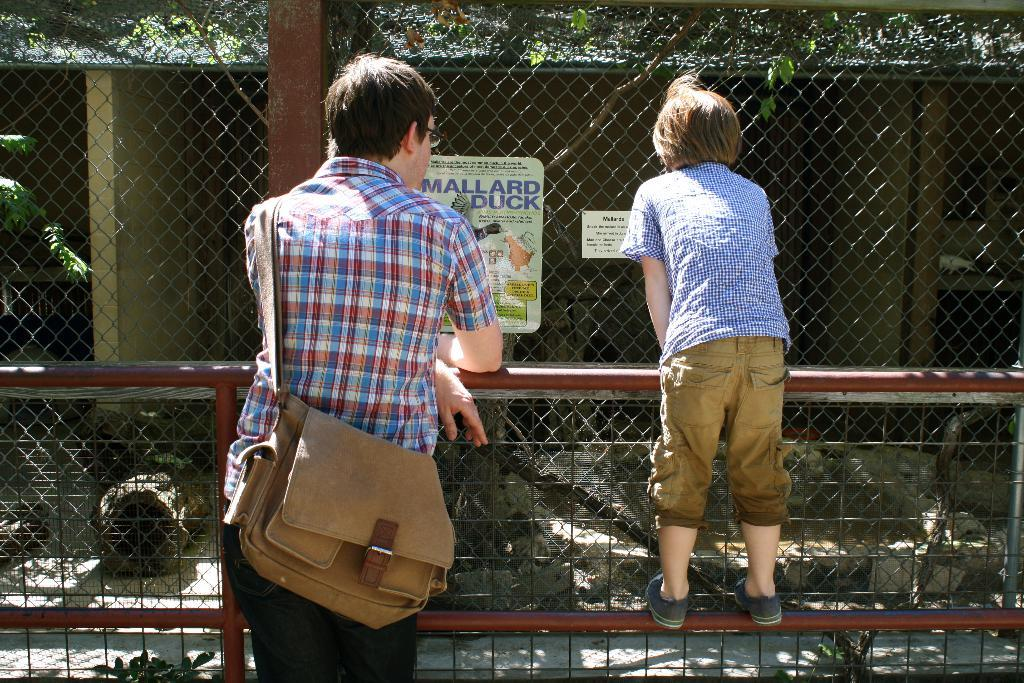How many persons can be seen in the image? There are persons in the image, but the exact number is not specified. What type of structure is present in the image? There is a fence in the image. What is the board used for in the image? The purpose of the board in the image is not specified. What can be seen in the background of the image? In the background of the image, there is a shelter, trees, the sky, and other objects. What type of guitar can be seen being played by the persons in the image? There is no guitar present in the image. Is there a volleyball game taking place in the background of the image? There is no volleyball game or any reference to a volleyball in the image. What type of quilt is draped over the shelter in the background of the image? There is no quilt present in the image. 